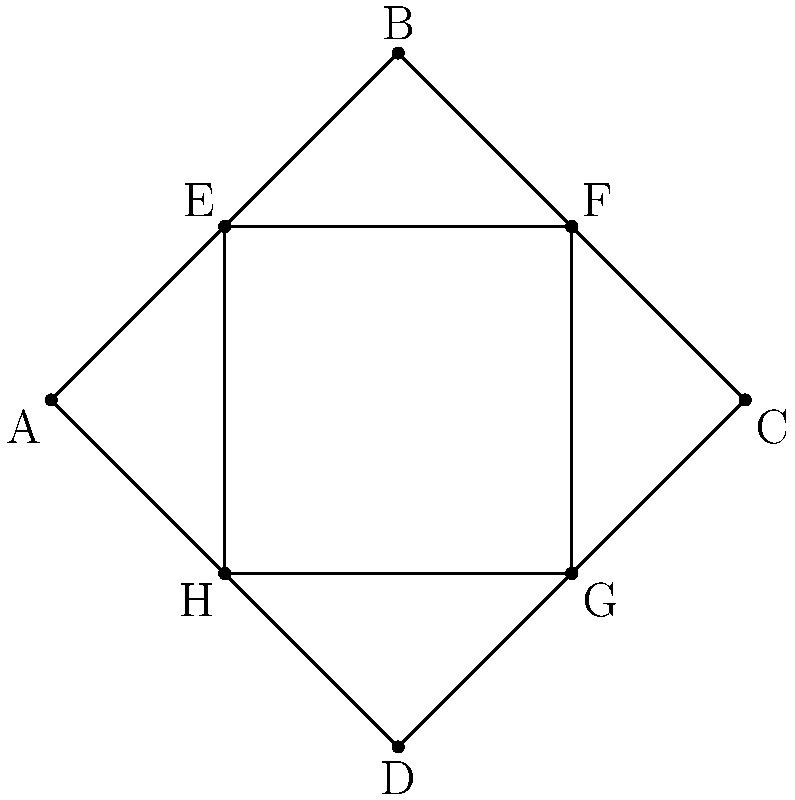In designing a diamond-shaped plant stand, you've created a rhombus ABCD with an inner rhombus EFGH. If the diagonals of ABCD intersect at the center of EFGH, how many pairs of congruent rhombuses can be identified in this design? Let's approach this step-by-step:

1) First, we need to identify all the rhombuses in the figure:
   - ABCD (the outer rhombus)
   - EFGH (the inner rhombus)
   - AEBF, BFCG, CGDH, DHAE (the four rhombuses formed by connecting the vertices of the inner and outer rhombuses)

2) Now, let's consider the congruence of these rhombuses:

   a) ABCD and EFGH:
      - These are not necessarily congruent as we don't have information about their sizes.

   b) AEBF, BFCG, CGDH, and DHAE:
      - Given that the diagonals of ABCD intersect at the center of EFGH, we can conclude that these four rhombuses are congruent to each other.
      - This is because the diagonals of a rhombus bisect each other, and the center of EFGH is the point where the diagonals of ABCD intersect.
      - Therefore, AE = BF = CG = DH, and EB = FC = GD = HA.

3) Counting the pairs of congruent rhombuses:
   - AEBF and BFCG
   - AEBF and CGDH
   - AEBF and DHAE
   - BFCG and CGDH
   - BFCG and DHAE
   - CGDH and DHAE

Therefore, we can identify 6 pairs of congruent rhombuses in this design.
Answer: 6 pairs 